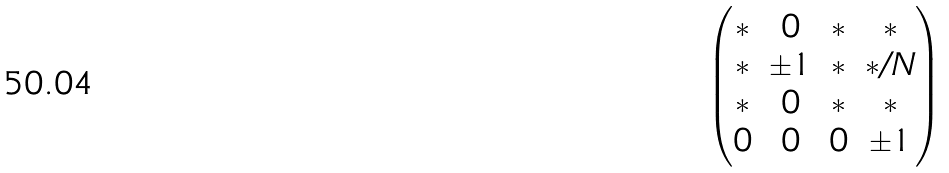<formula> <loc_0><loc_0><loc_500><loc_500>\begin{pmatrix} * & 0 & * & * \\ * & \pm 1 & * & * / N \\ * & 0 & * & * \\ 0 & 0 & 0 & \pm 1 \end{pmatrix}</formula> 